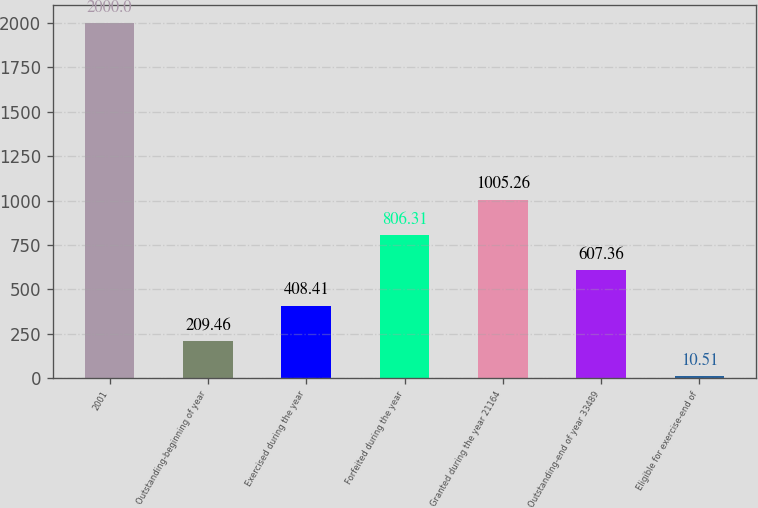Convert chart. <chart><loc_0><loc_0><loc_500><loc_500><bar_chart><fcel>2001<fcel>Outstanding-beginning of year<fcel>Exercised during the year<fcel>Forfeited during the year<fcel>Granted during the year 21164<fcel>Outstanding-end of year 33489<fcel>Eligible for exercise-end of<nl><fcel>2000<fcel>209.46<fcel>408.41<fcel>806.31<fcel>1005.26<fcel>607.36<fcel>10.51<nl></chart> 